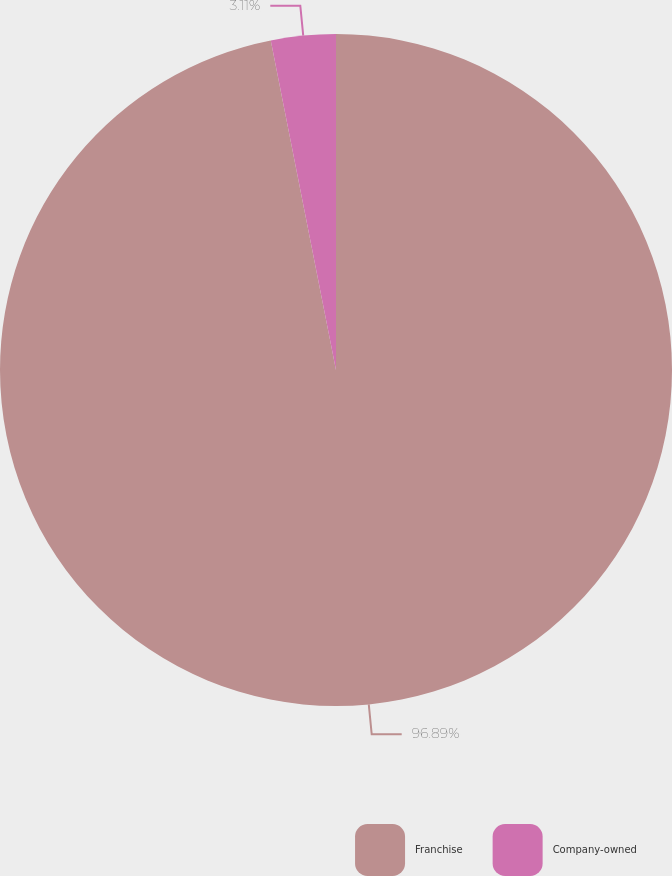Convert chart to OTSL. <chart><loc_0><loc_0><loc_500><loc_500><pie_chart><fcel>Franchise<fcel>Company-owned<nl><fcel>96.89%<fcel>3.11%<nl></chart> 